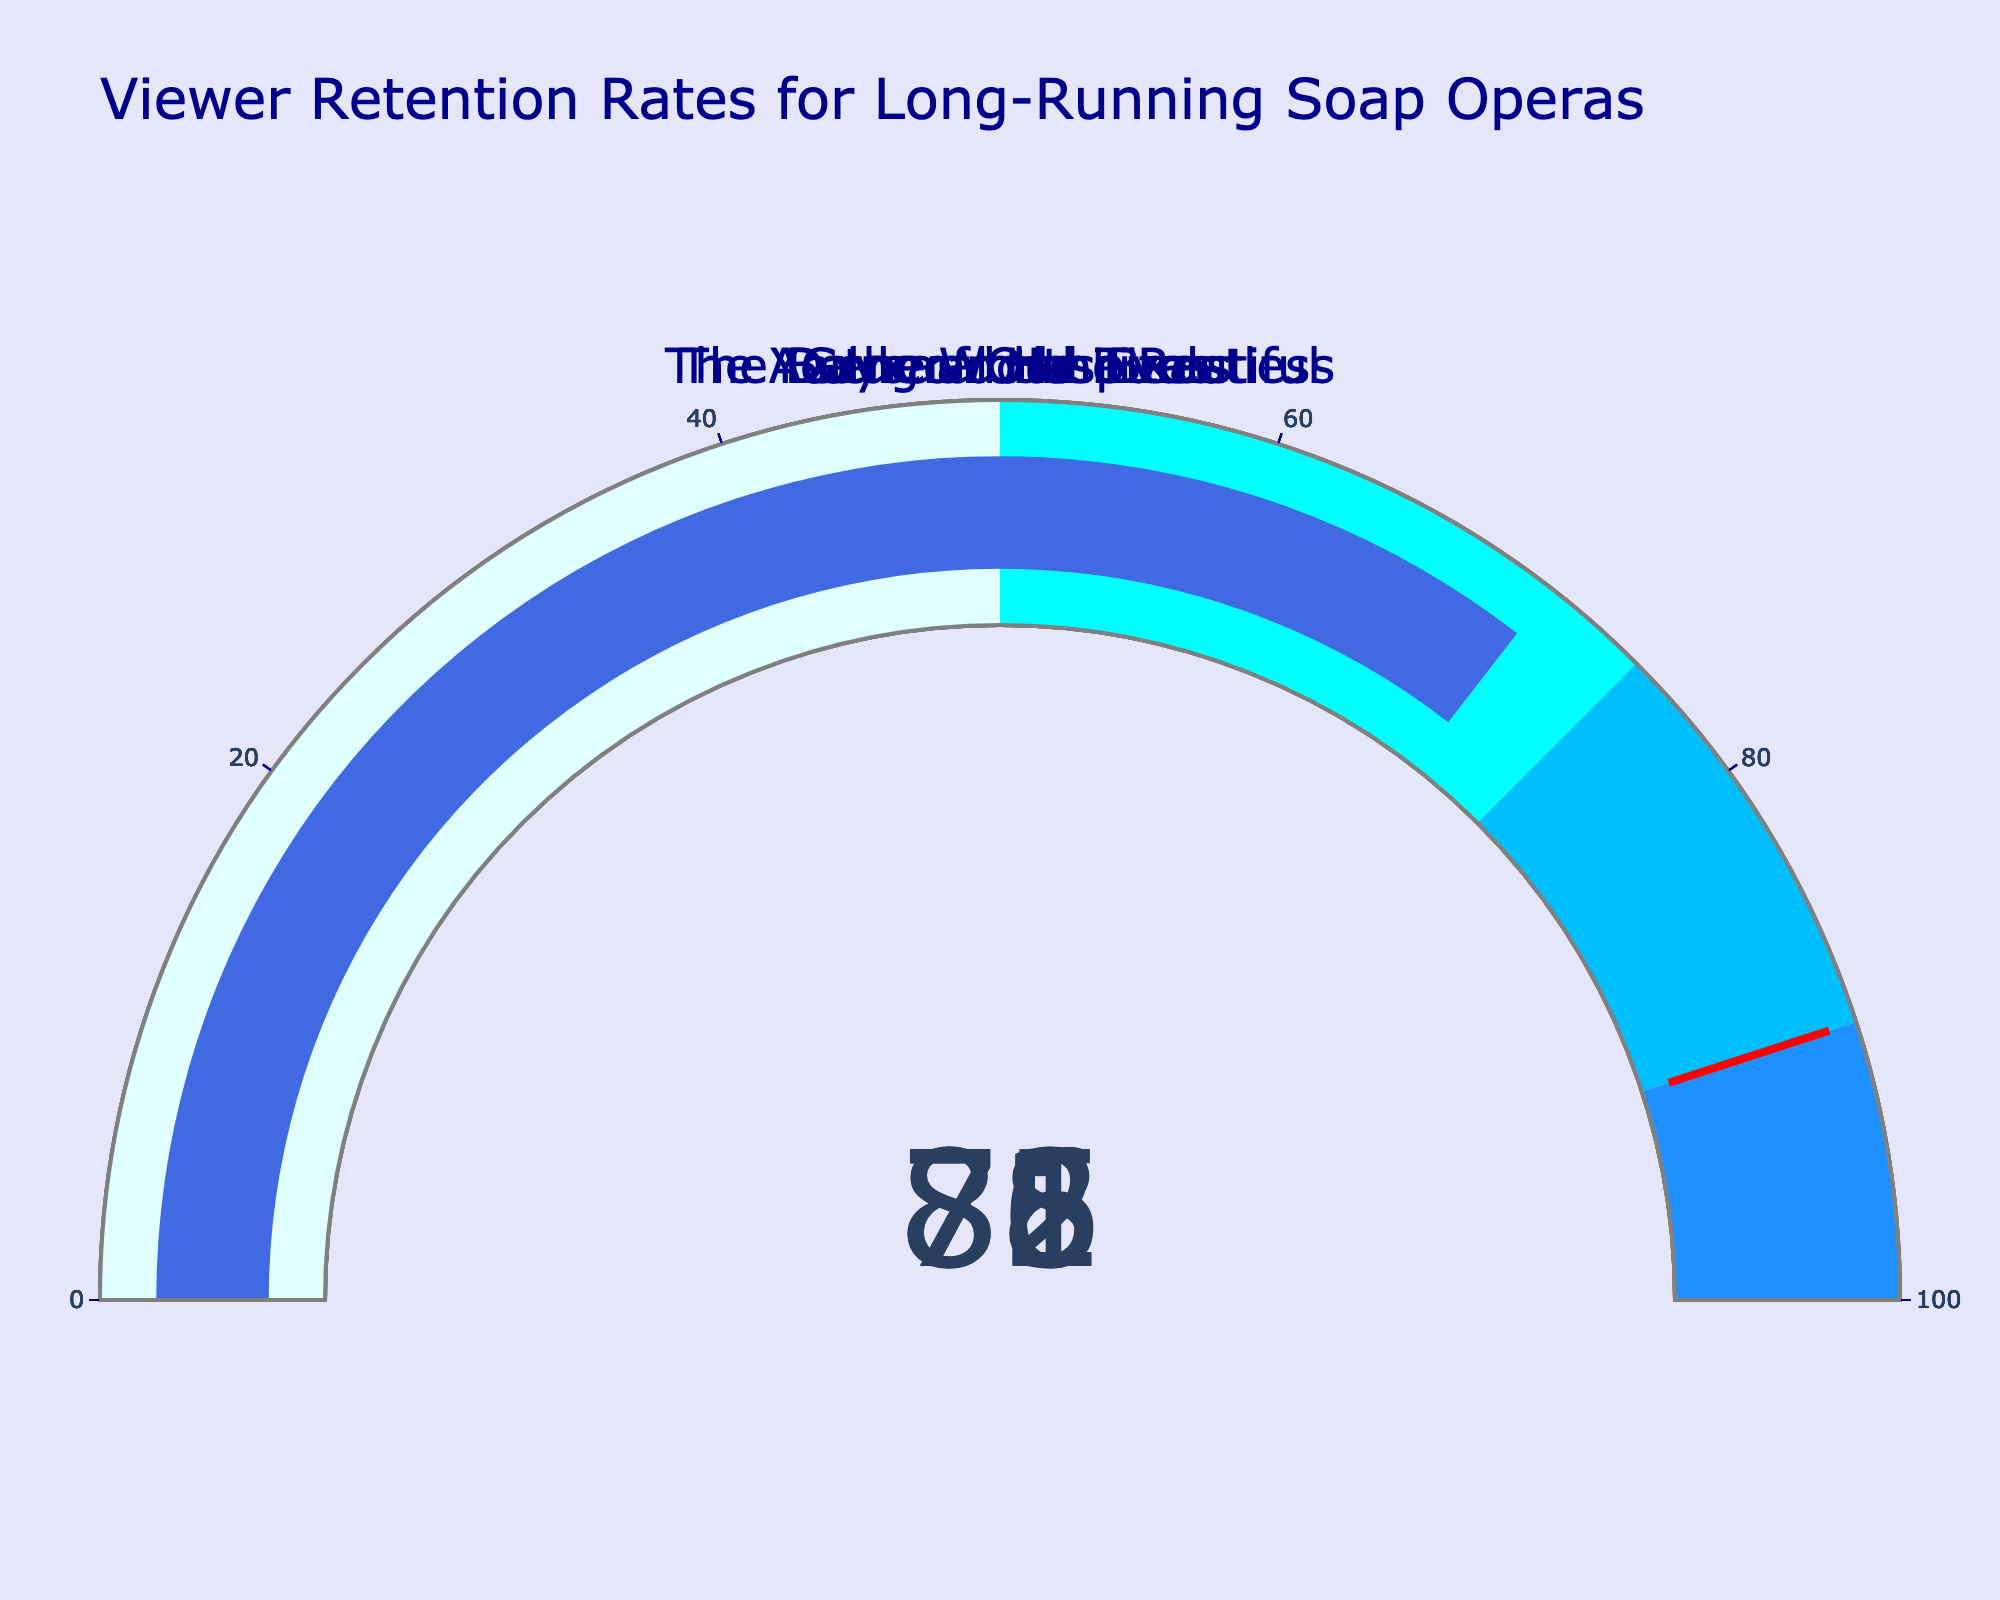what is the title of the figure? The title of the figure can be found at the top and usually explains what the entire figure is about. For the given figure, the title is "Viewer Retention Rates for Long-Running Soap Operas".
Answer: Viewer Retention Rates for Long-Running Soap Operas how many shows have a retention rate greater than 80? By looking at the values in each gauge, we see that "General Hospital" and "The Young and the Restless" have retention rates greater than 80. This makes it 2 shows.
Answer: 2 which show has the highest retention rate? To determine the show with the highest retention rate, we compare the values on all the gauges. "The Young and the Restless" has the highest retention rate with a value of 85.
Answer: The Young and the Restless what is the range of values displayed on the gauges? The gauges feature a scale that ranges from 0 to 100, evident from the provided axis' range.
Answer: 0 to 100 is there any show with a retention rate below 75? By checking the values on each gauge, we find that "The Bold and the Beautiful" (76) and "As the World Turns" (71) are the only shows below the 75 value. So, "As the World Turns" meets this condition.
Answer: As the World Turns what is the average retention rate of all the shows? Calculate the average by summing the retention rates (78 + 82 + 85 + 76 + 71 = 392) and then dividing by the number of shows (5). The average retention rate is 392/5 = 78.4.
Answer: 78.4 how many shows have a retention rate in the 75-90 range? A retention rate falling between 75 and 90 includes gauges with values in this interval. "Days of Our Lives", "General Hospital", "The Young and the Restless", and "The Bold and the Beautiful" all have retention rates within this range, making it 4 shows.
Answer: 4 which shows have a retention rate above the threshold value? The threshold value is indicated by a red line at 90. No show's retention rate crosses this 90-mark threshold, so the answer is none.
Answer: None 